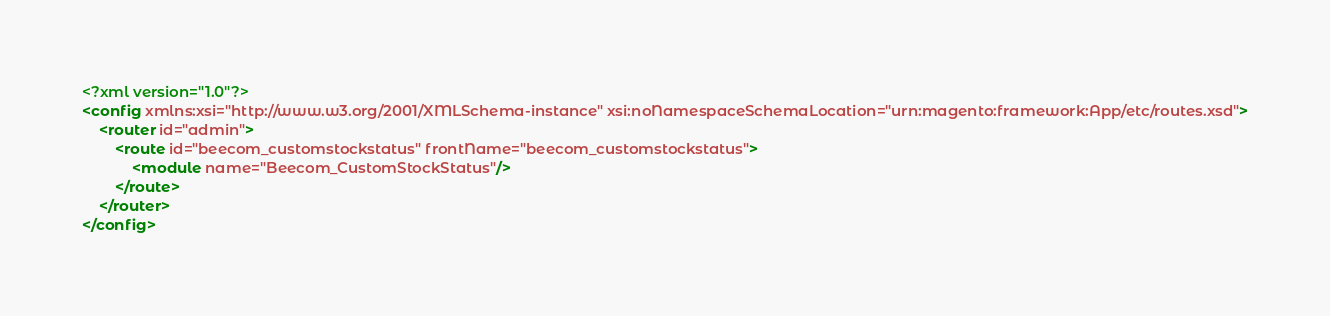Convert code to text. <code><loc_0><loc_0><loc_500><loc_500><_XML_><?xml version="1.0"?>
<config xmlns:xsi="http://www.w3.org/2001/XMLSchema-instance" xsi:noNamespaceSchemaLocation="urn:magento:framework:App/etc/routes.xsd">
    <router id="admin">
        <route id="beecom_customstockstatus" frontName="beecom_customstockstatus">
            <module name="Beecom_CustomStockStatus"/>
        </route>
    </router>
</config>
</code> 